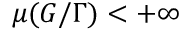Convert formula to latex. <formula><loc_0><loc_0><loc_500><loc_500>\mu ( G / \Gamma ) < + \infty</formula> 